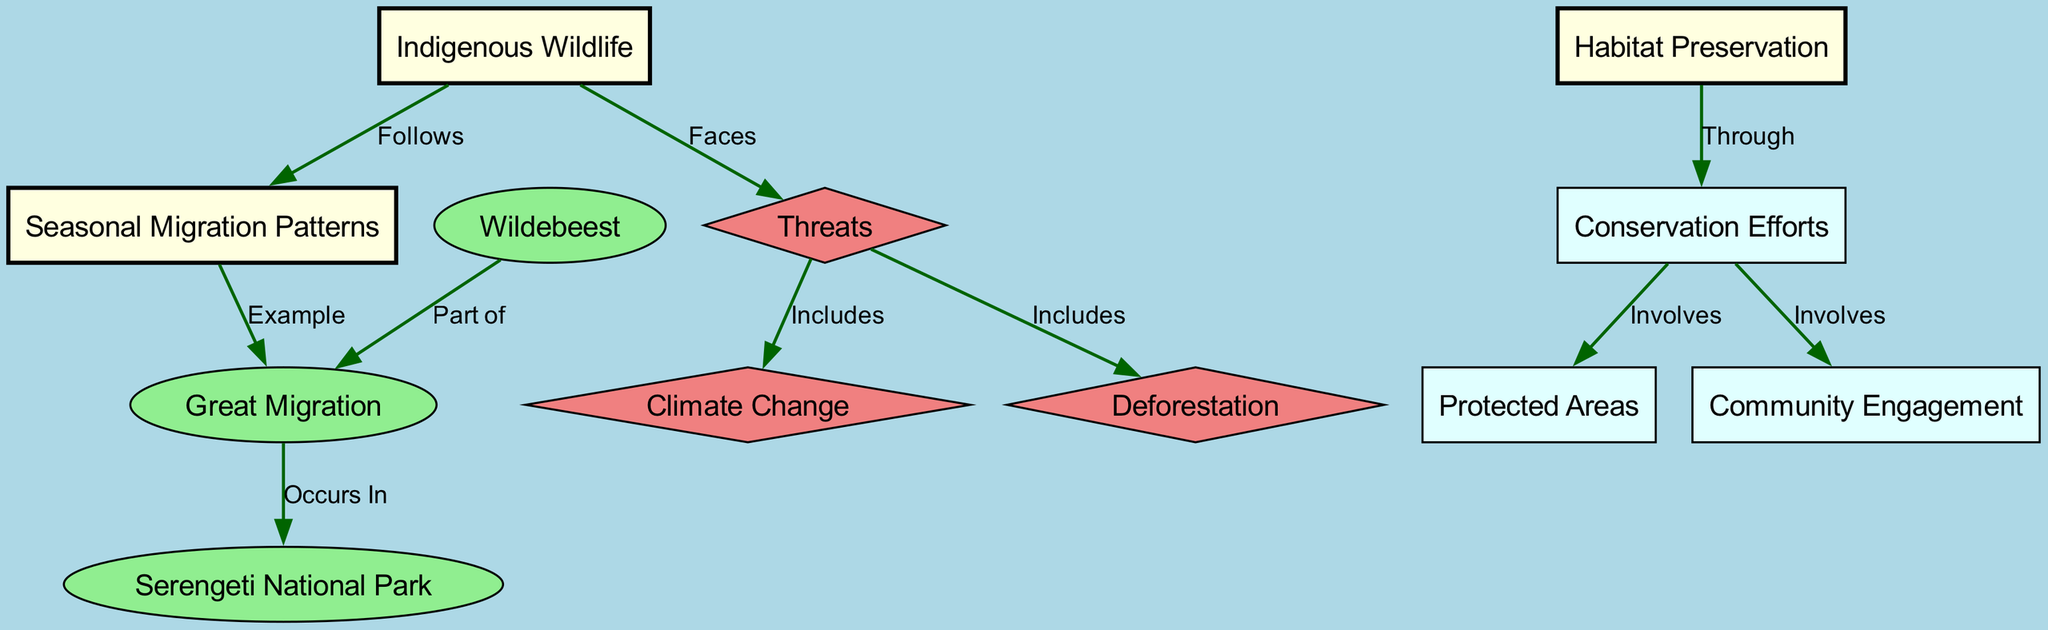What is the main indigenous wildlife that follows seasonal migration patterns? The diagram indicates that "Indigenous Wildlife" is linked with "Seasonal Migration Patterns," and specifies that "Wildebeest" is part of the "Great Migration," which is an example of these patterns. Therefore, the main indigenous wildlife is "Wildebeest."
Answer: Wildebeest How many nodes are present in the diagram? By counting all the individual nodes listed in the data (including those representing wildlife, threats, and preservation efforts), we find a total of 12 nodes.
Answer: 12 What is a major threat to indigenous wildlife? The diagram shows the "Threats" node connected to both "Climate Change" and "Deforestation," clearly indicating that these are significant threats faced by indigenous wildlife.
Answer: Climate Change In which national park does the Great Migration occur? Since the diagram connects "Great Migration" to "Serengeti National Park" with an "Occurs In" label, this specifies that the migration occurs in that location.
Answer: Serengeti National Park What type of efforts are involved in habitat preservation? The diagram connects "Habitat Preservation" to "Conservation Efforts" through the label "Through." This indicates that conservation efforts are a type of action involved in habitat preservation.
Answer: Conservation Efforts Which aspect of habitat preservation involves community involvement? The diagram indicates that "Community Engagement" is a component of "Conservation Efforts." Since conservation efforts are linked to habitat preservation, community involvement is part of that connection.
Answer: Community Engagement What animal is part of the Great Migration? The diagram establishes a connection between "Wildebeest" and "Great Migration," detailing that wildebeests are part of this crucial seasonal movement.
Answer: Wildebeest What relationship exists between threats and climate change? The diagram specifies a direct relationship where "Threats" includes "Climate Change," showing how climate change contributes to the overall threats faced by wildlife.
Answer: Includes What does habitat preservation involve to maintain protected areas? The diagram indicates that "Conservation Efforts" involves "Protected Areas," signifying that maintaining protected areas is part of the efforts dedicated to habitat preservation.
Answer: Protected Areas 